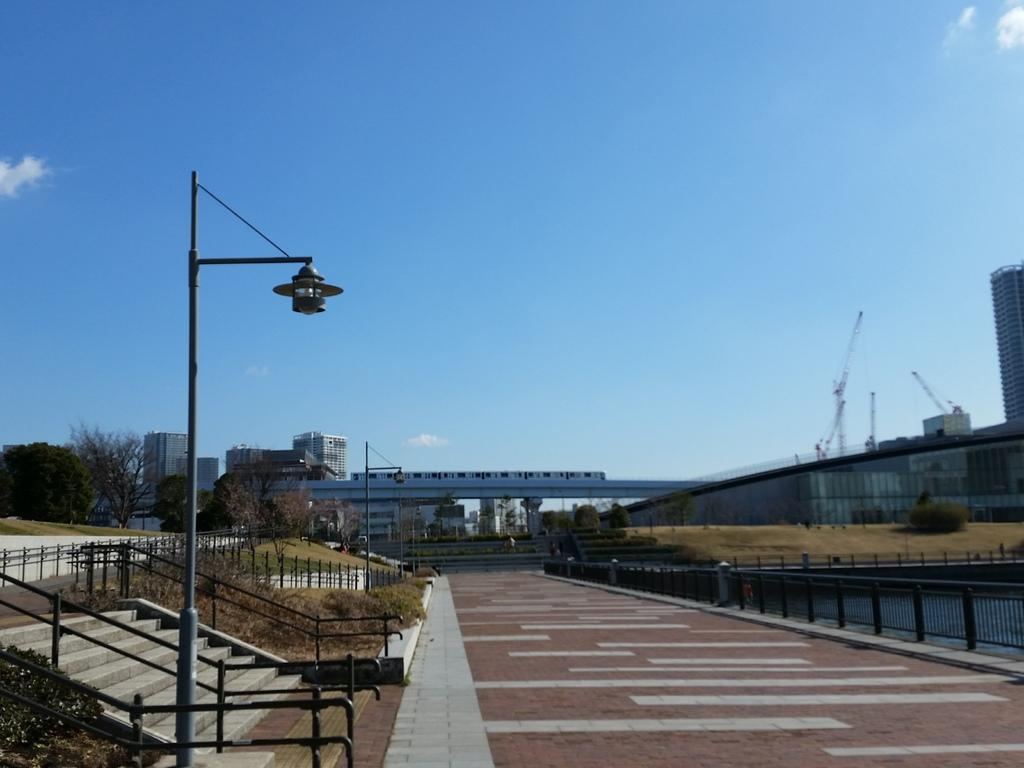What type of surface can be seen in the image? There is a road in the image. What type of structures are present in the image? Store cases are visible in the image. What type of vegetation is present in the image? Grass and trees are visible in the image. What type of barrier is present in the image? There is fencing in the image. What type of structures can be seen in the background of the image? There are buildings in the background of the image. What type of account does the dog have in the image? There is no dog present in the image, so it is not possible to determine if it has an account. What type of teeth can be seen in the image? There are no teeth visible in the image. 